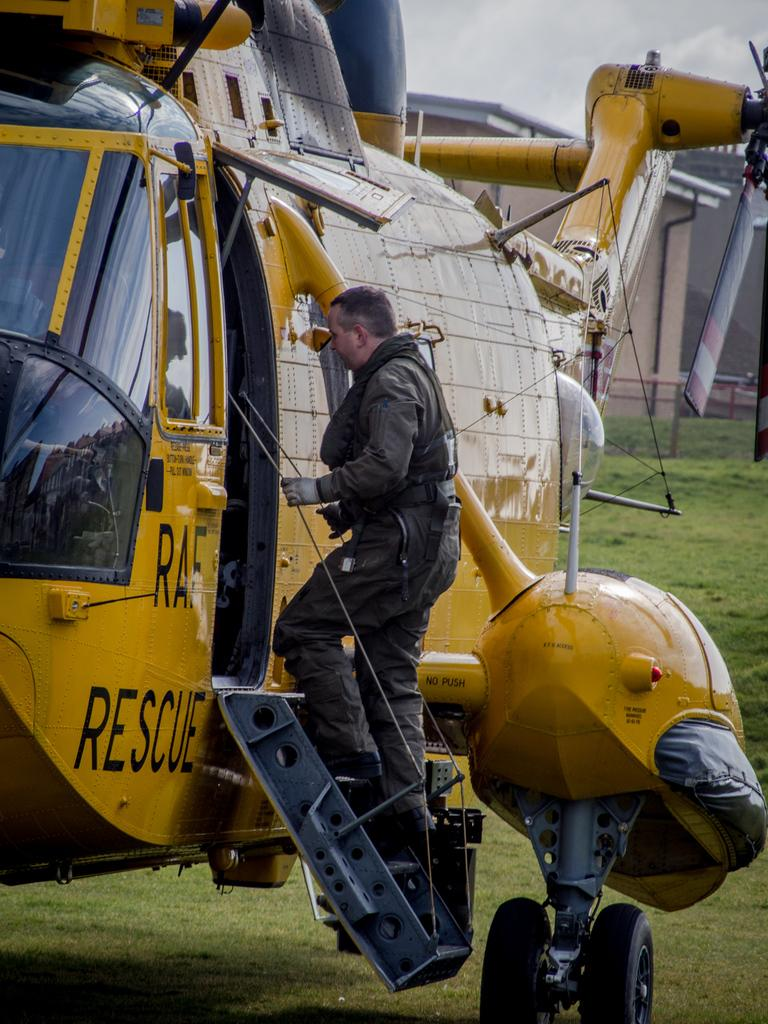<image>
Relay a brief, clear account of the picture shown. A man boards a yellow rescue helicopter which belongs to the RAF. 